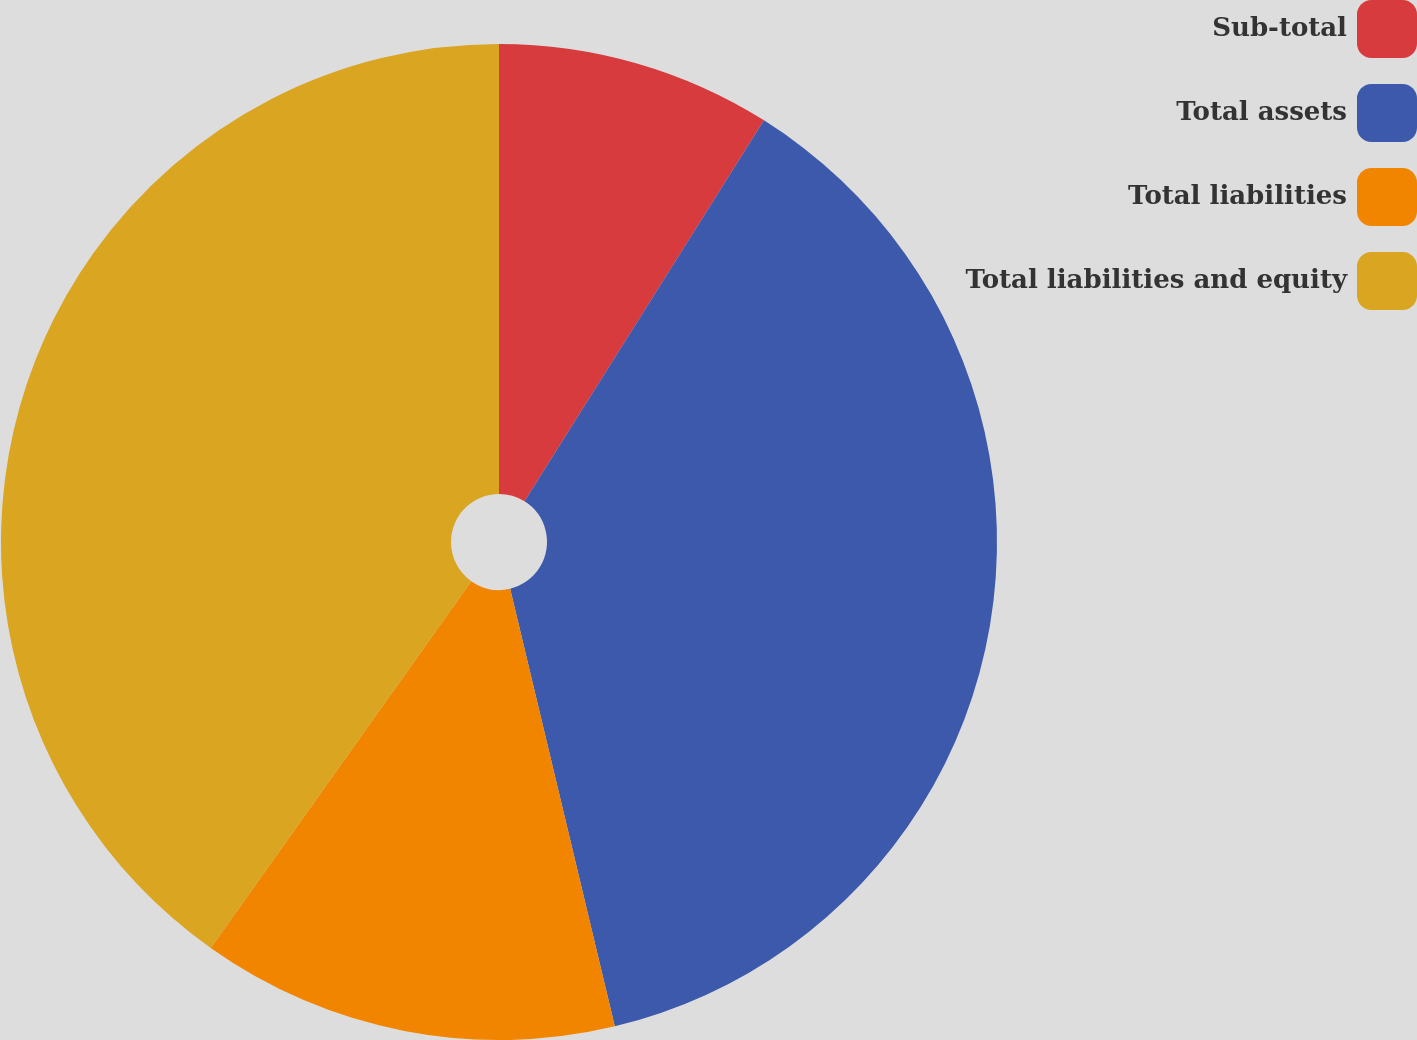<chart> <loc_0><loc_0><loc_500><loc_500><pie_chart><fcel>Sub-total<fcel>Total assets<fcel>Total liabilities<fcel>Total liabilities and equity<nl><fcel>8.93%<fcel>37.33%<fcel>13.56%<fcel>40.17%<nl></chart> 